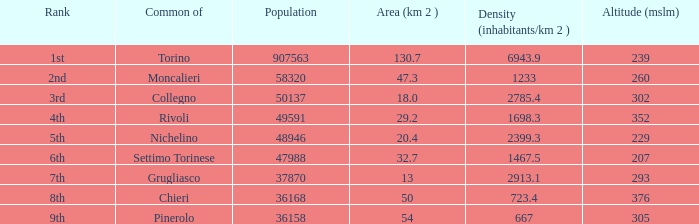What rank is the common with an area of 47.3 km^2? 2nd. 